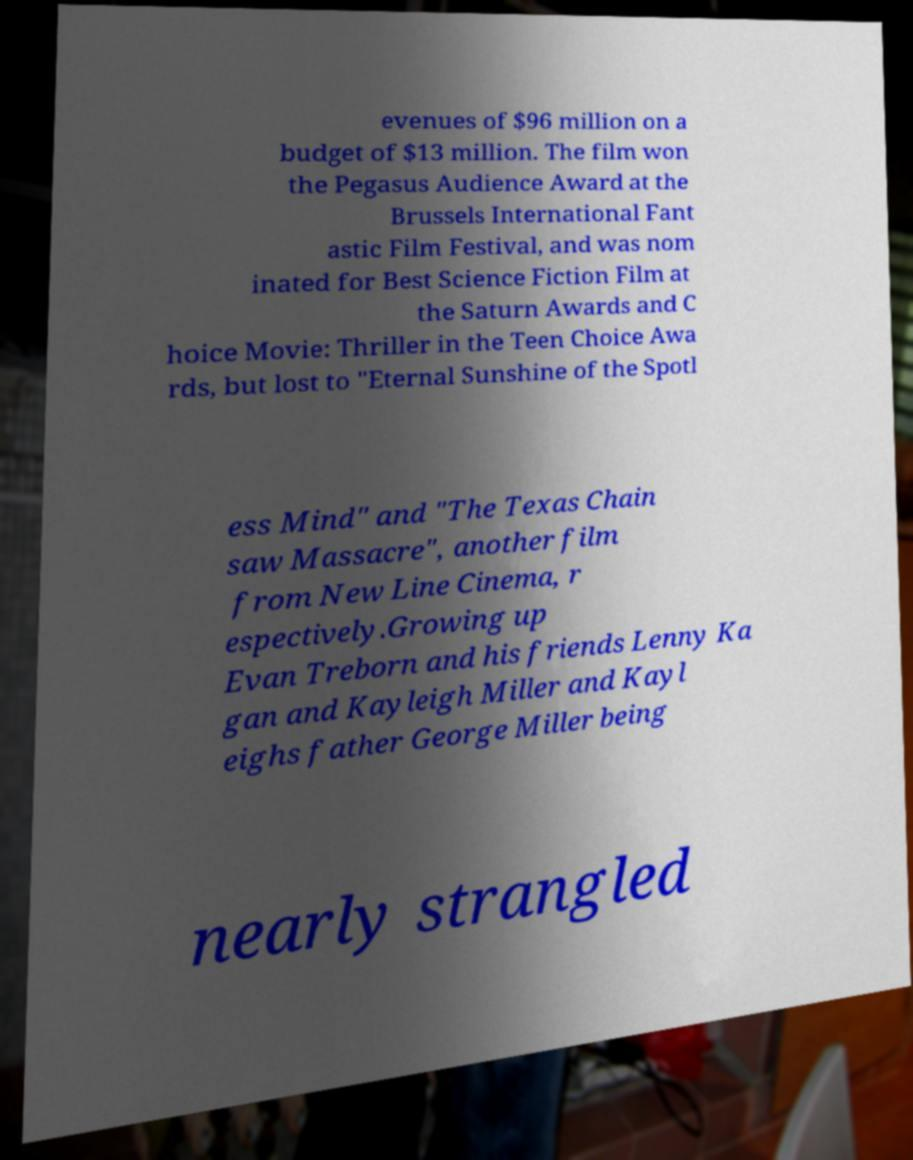Could you extract and type out the text from this image? evenues of $96 million on a budget of $13 million. The film won the Pegasus Audience Award at the Brussels International Fant astic Film Festival, and was nom inated for Best Science Fiction Film at the Saturn Awards and C hoice Movie: Thriller in the Teen Choice Awa rds, but lost to "Eternal Sunshine of the Spotl ess Mind" and "The Texas Chain saw Massacre", another film from New Line Cinema, r espectively.Growing up Evan Treborn and his friends Lenny Ka gan and Kayleigh Miller and Kayl eighs father George Miller being nearly strangled 